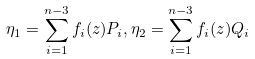<formula> <loc_0><loc_0><loc_500><loc_500>\eta _ { 1 } = \sum _ { i = 1 } ^ { n - 3 } f _ { i } ( z ) P _ { i } , \eta _ { 2 } = \sum _ { i = 1 } ^ { n - 3 } f _ { i } ( z ) Q _ { i }</formula> 